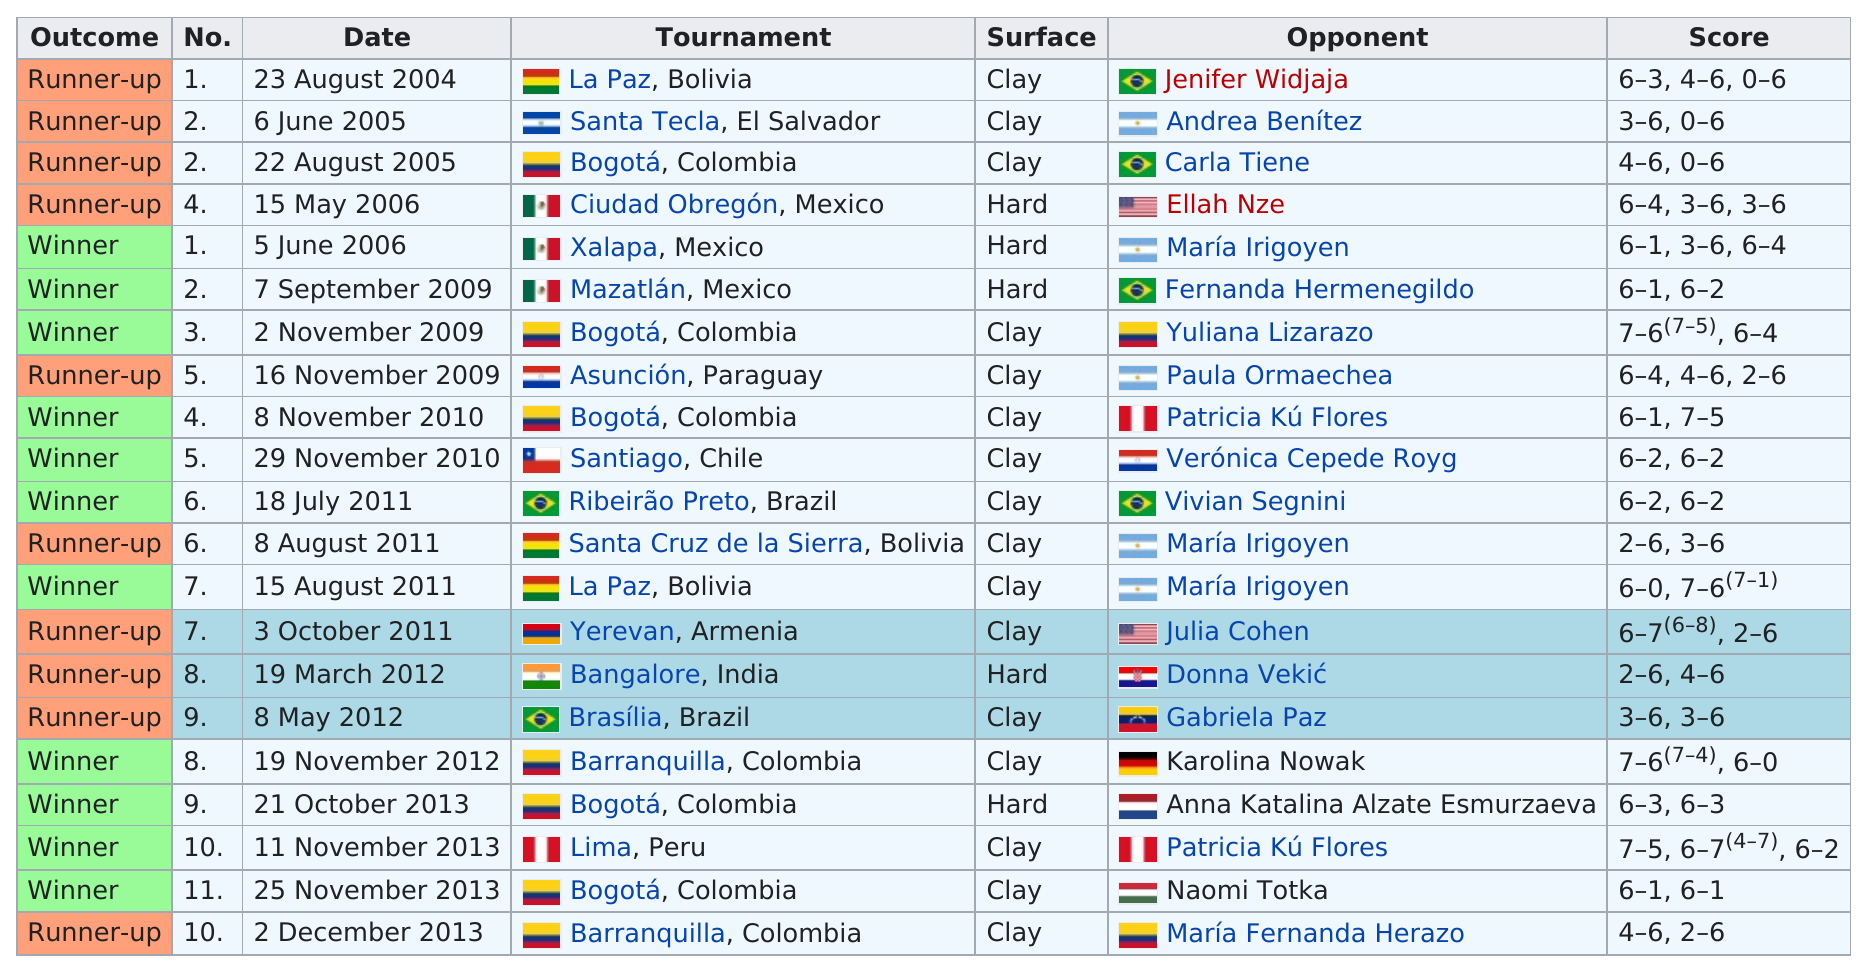Draw attention to some important aspects in this diagram. In 2009, Andrea Koch Benvenuto won more tournaments than in 2006. Andrew Koch won the tournament in Bogotá, Colombia. The speaker is referring to a tournament that was won by a female tennis player in Bogotá, Colombia. There are 5 hard surface courts available. There was a winner 11 times. 